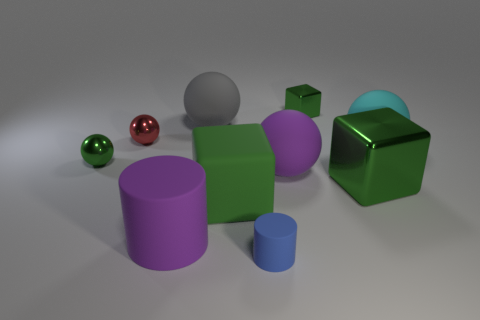There is a small shiny sphere left of the red metallic ball; how many large purple rubber cylinders are on the left side of it?
Offer a very short reply. 0. There is a big ball that is on the left side of the big metal object and to the right of the tiny cylinder; what material is it made of?
Ensure brevity in your answer.  Rubber. What is the shape of the gray thing that is the same size as the cyan matte sphere?
Give a very brief answer. Sphere. There is a tiny metal thing that is right of the purple thing that is to the left of the large thing that is behind the large cyan matte object; what is its color?
Your answer should be very brief. Green. What number of things are metallic objects that are left of the purple matte sphere or big green matte blocks?
Offer a terse response. 3. What material is the cylinder that is the same size as the red metallic sphere?
Keep it short and to the point. Rubber. There is a purple thing that is on the right side of the large cylinder to the left of the small green shiny thing that is right of the tiny red shiny thing; what is its material?
Your answer should be compact. Rubber. What is the color of the big shiny block?
Offer a very short reply. Green. How many large things are green matte balls or rubber objects?
Keep it short and to the point. 5. There is a ball that is the same color as the big cylinder; what is it made of?
Keep it short and to the point. Rubber. 